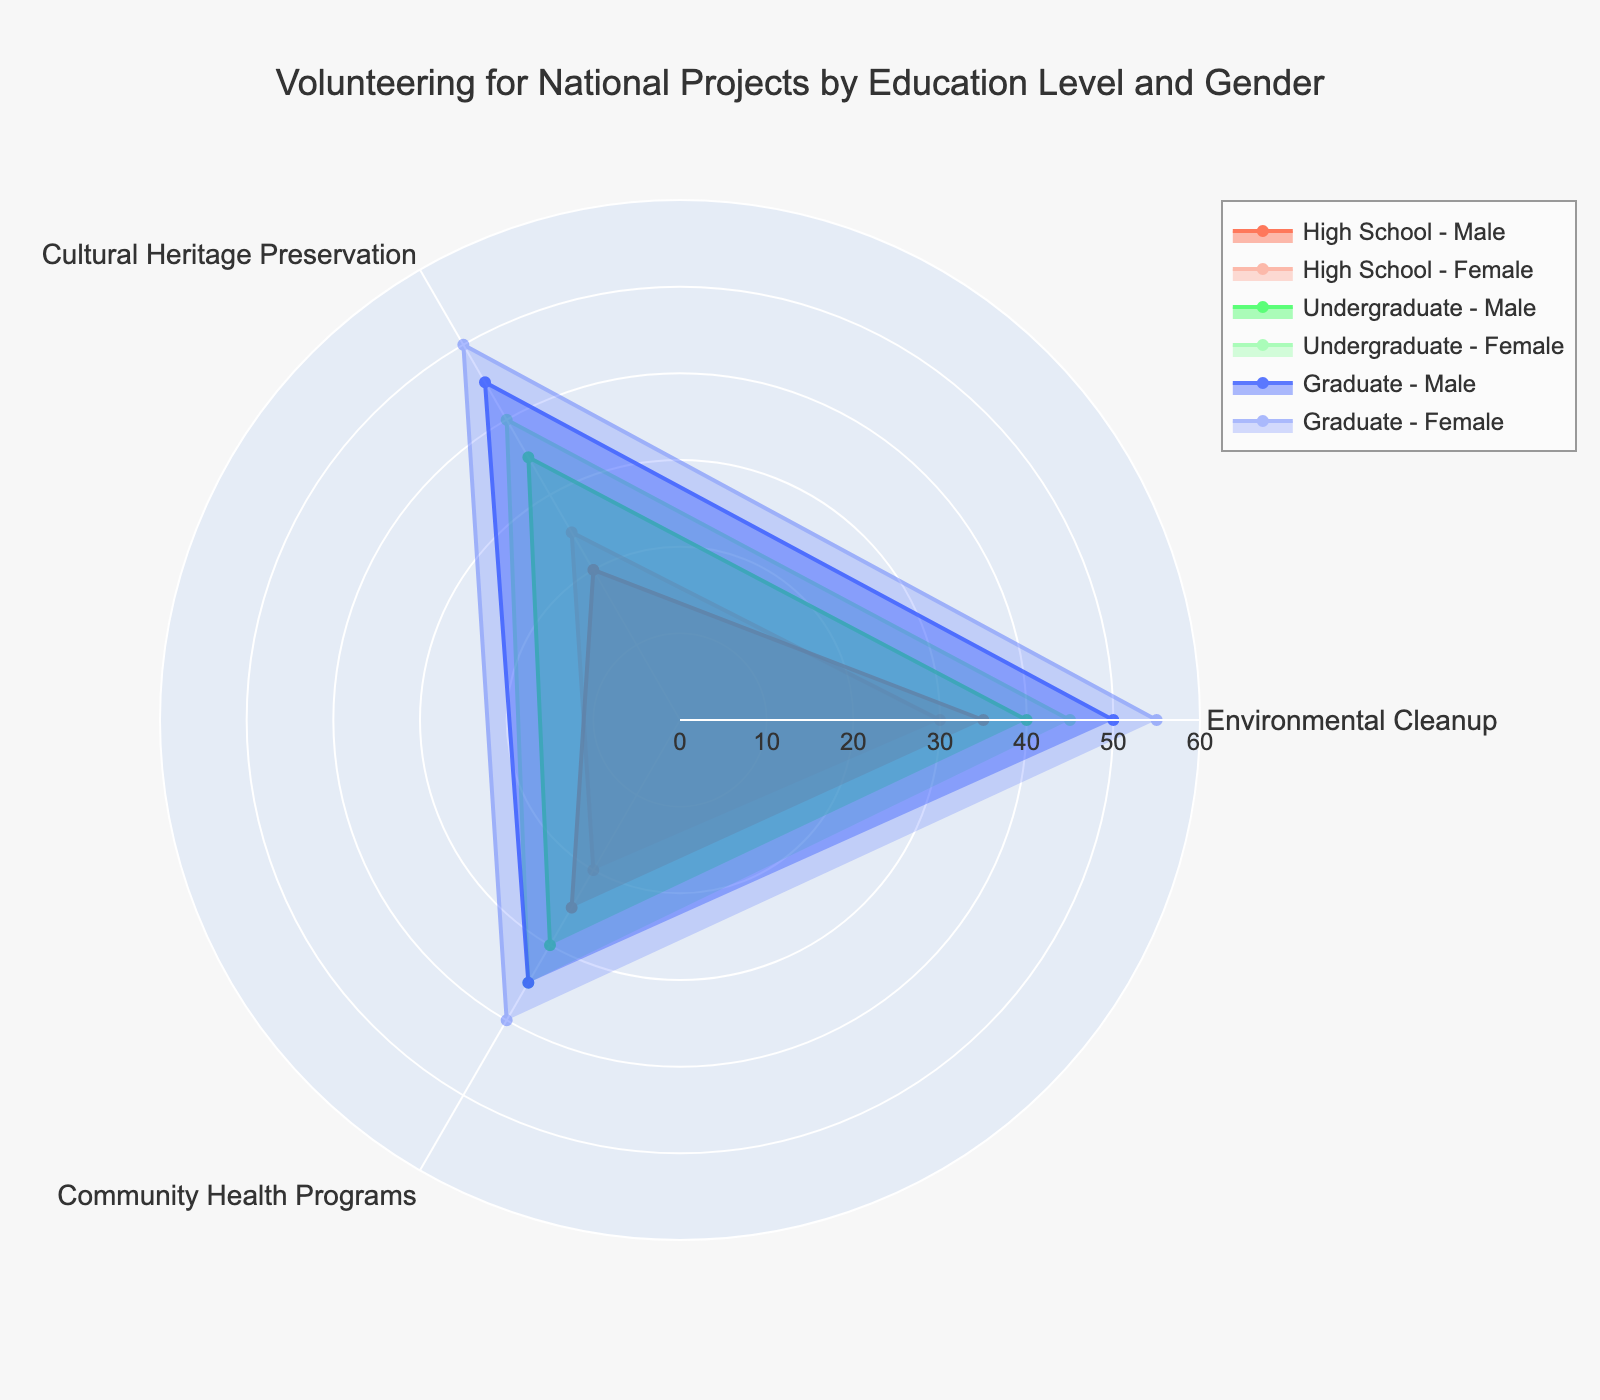What is the title of the chart? The main header or heading of the chart is typically located at the top and gives a summary of what the chart represents. Checking at the top of the chart, you'll see "Volunteering for National Projects by Education Level and Gender".
Answer: Volunteering for National Projects by Education Level and Gender How many categories of volunteering activities are shown in the radar chart? Categories can be identified by inspecting the axes or labels around the radar chart. Here, you can see that the chart has spokes or axes labeled "Environmental Cleanup," "Cultural Heritage Preservation," and "Community Health Programs".
Answer: 3 Which group has the highest value for "Cultural Heritage Preservation"? To determine this, observe the points on the "Cultural Heritage Preservation" axis for all groups. The group with the highest value will have the farthest point from the center. "Female - Graduate" has the highest point on this axis, which corresponds to a value of 50.
Answer: Female - Graduate What's the average score of the "Graduate - Female" group across all three categories? Add the values for Environmental Cleanup (55), Cultural Heritage Preservation (50), and Community Health Programs (40), then divide by 3 to get the average: (55 + 50 + 40) / 3 = 145 / 3 ≈ 48.3
Answer: 48.3 Compare the levels of participation in "Community Health Programs" for high school and undergraduate males. Which group participates more? Look at the values along the "Community Health Programs" axis for both groups. High school males have a value of 25, while undergraduate males have a value of 30. 30 is greater than 25.
Answer: Undergraduate males For which education level do females have a higher value than males in the "Environmental Cleanup" category? Compare the values for males and females at each education level for "Environmental Cleanup": High School: Male (35), Female (30); Undergraduate: Male (40), Female (45); Graduate: Male (50), Female (55). Only at the undergraduate and graduate levels do females have higher values than males.
Answer: Undergraduate and Graduate What is the difference in participation between "Male - High School" and "Female - Undergraduate" in "Environmental Cleanup"? Subtract the value for "Male - High School" in Environmental Cleanup (35) from the value for "Female - Undergraduate" in Environmental Cleanup (45): 45 - 35 = 10.
Answer: 10 In which category do "High School - Female" scores exceed those of "High School - Male"? Compare the values of each category for high school males and females. For Cultural Heritage Preservation: Male (20), Female (25), Female's value is higher.
Answer: Cultural Heritage Preservation Which education level shows the greatest overall participation improvement from high school to graduate for both genders in "Environmental Cleanup"? Calculate the increase in participation from high school to graduate level for males and females. For males: Graduate (50) - High School (35) = 15. For females: Graduate (55) - High School (30) = 25. Since both genders show improvement, note the highest improvement, which is found in females.
Answer: Female 